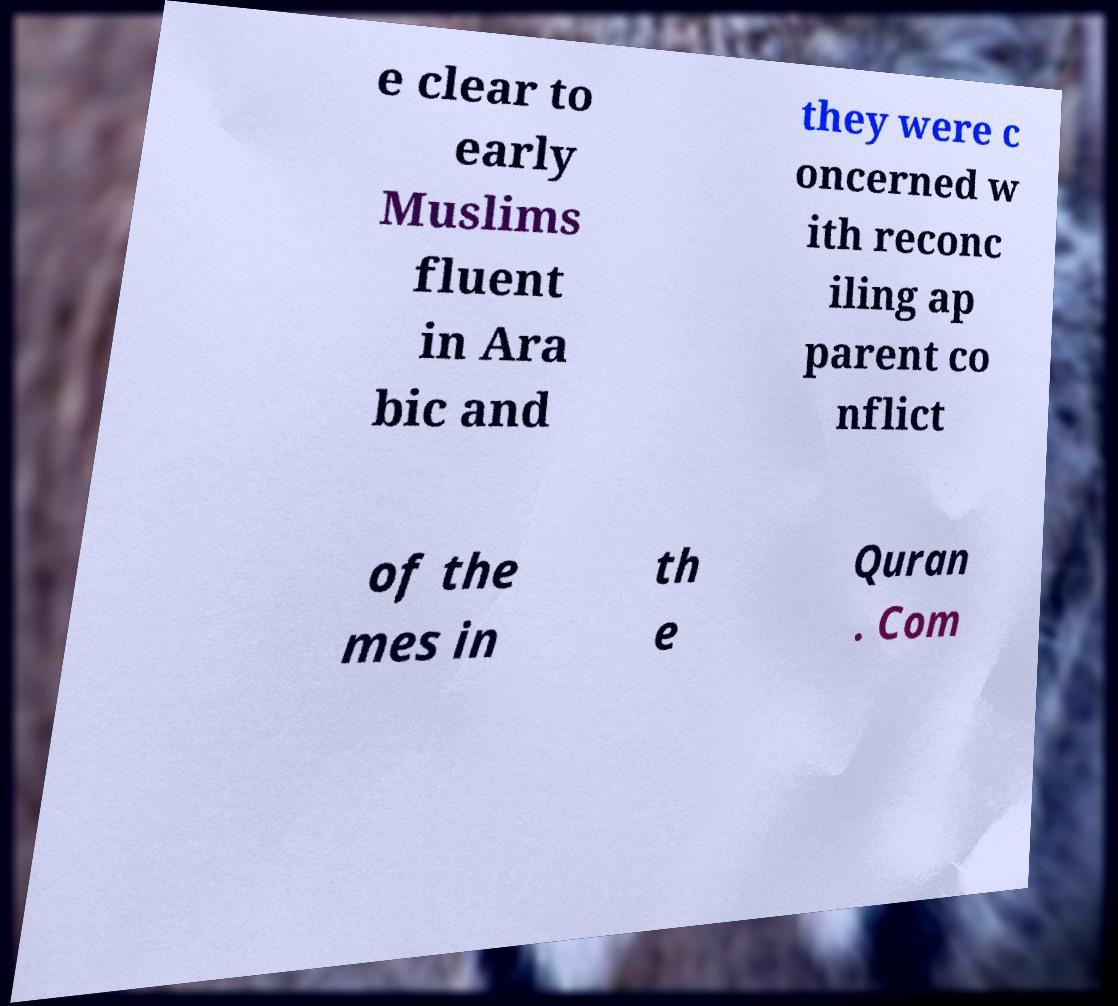Can you accurately transcribe the text from the provided image for me? e clear to early Muslims fluent in Ara bic and they were c oncerned w ith reconc iling ap parent co nflict of the mes in th e Quran . Com 